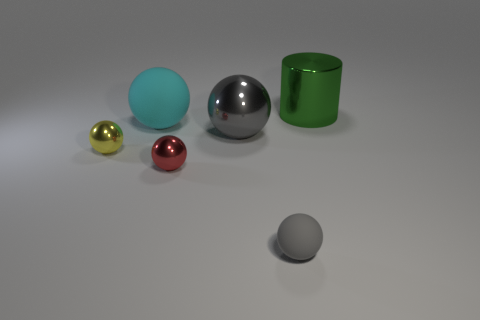Is the number of small gray matte balls on the right side of the metallic cylinder less than the number of green things left of the gray metal sphere?
Make the answer very short. No. Does the tiny metal sphere that is left of the red object have the same color as the large shiny thing on the left side of the green shiny thing?
Offer a very short reply. No. The object that is both left of the small red shiny ball and on the right side of the yellow thing is made of what material?
Keep it short and to the point. Rubber. Are any small yellow spheres visible?
Your response must be concise. Yes. What shape is the big green thing that is the same material as the large gray thing?
Ensure brevity in your answer.  Cylinder. Does the small red object have the same shape as the gray object that is in front of the tiny yellow object?
Your answer should be very brief. Yes. There is a large ball that is behind the large metal object that is to the left of the large green metallic thing; what is its material?
Your answer should be very brief. Rubber. How many other objects are there of the same shape as the big gray shiny thing?
Provide a succinct answer. 4. Is the shape of the large object that is on the right side of the gray metallic ball the same as the rubber object that is to the right of the large matte ball?
Keep it short and to the point. No. Is there any other thing that has the same material as the small gray ball?
Provide a short and direct response. Yes. 